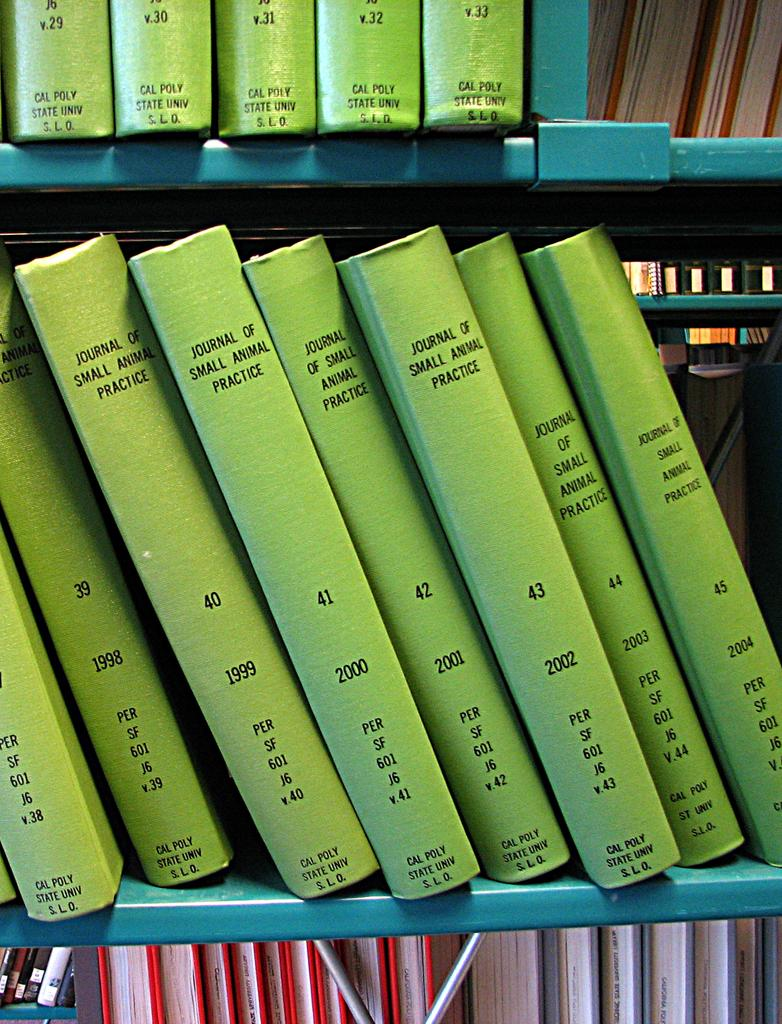<image>
Summarize the visual content of the image. a shelf with several books about small animal practice 